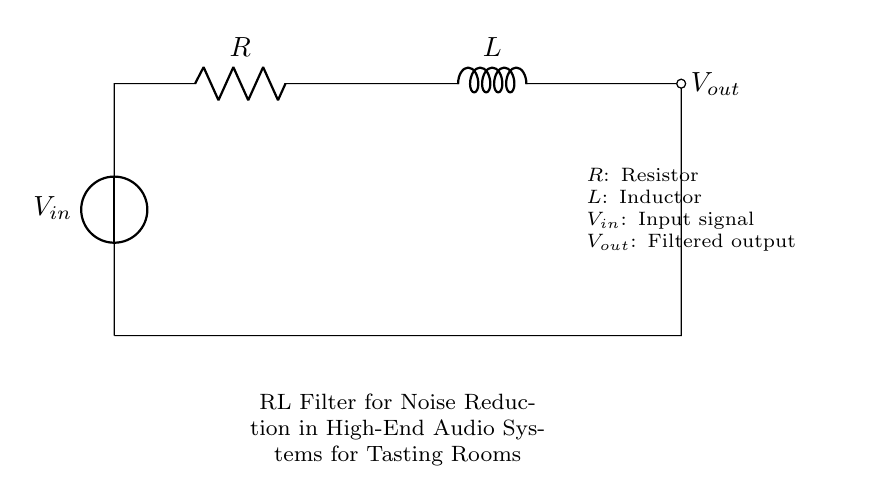What is the input voltage in this circuit? The diagram indicates the input voltage is labeled as V subscript in, which represents the voltage input to the circuit.
Answer: V in What components are used in this circuit? The circuit comprises a resistor, an inductor, and an input and output voltage source. These components are essential for the functioning of an RL filter.
Answer: Resistor, Inductor What is the role of the inductor in this circuit? The inductor in this RL filter circuit helps to filter out high-frequency noise by resisting changes in current, allowing only the desired signals through.
Answer: Noise reduction What is the output notation for this circuit? The output of this circuit is represented as V subscript out in the diagram, indicating the filtered signal after passing through the resistor and inductor.
Answer: V out What happens to high-frequency signals in this circuit? High-frequency signals are attenuated by the inductor, which presents higher impedance to these signals compared to lower frequencies, leading to effective noise reduction.
Answer: Attenuated What type of filter is this circuit classified as? This circuit is classified as a low-pass filter because it allows low-frequency signals to pass while attenuating high-frequency noise, which is characteristic of RL filters.
Answer: Low-pass filter What labels are present in the diagram? The labels present in the diagram include V in for the input voltage, V out for the output voltage, R for the resistor, and L for the inductor. These labels clarify component functions.
Answer: V in, V out, R, L 